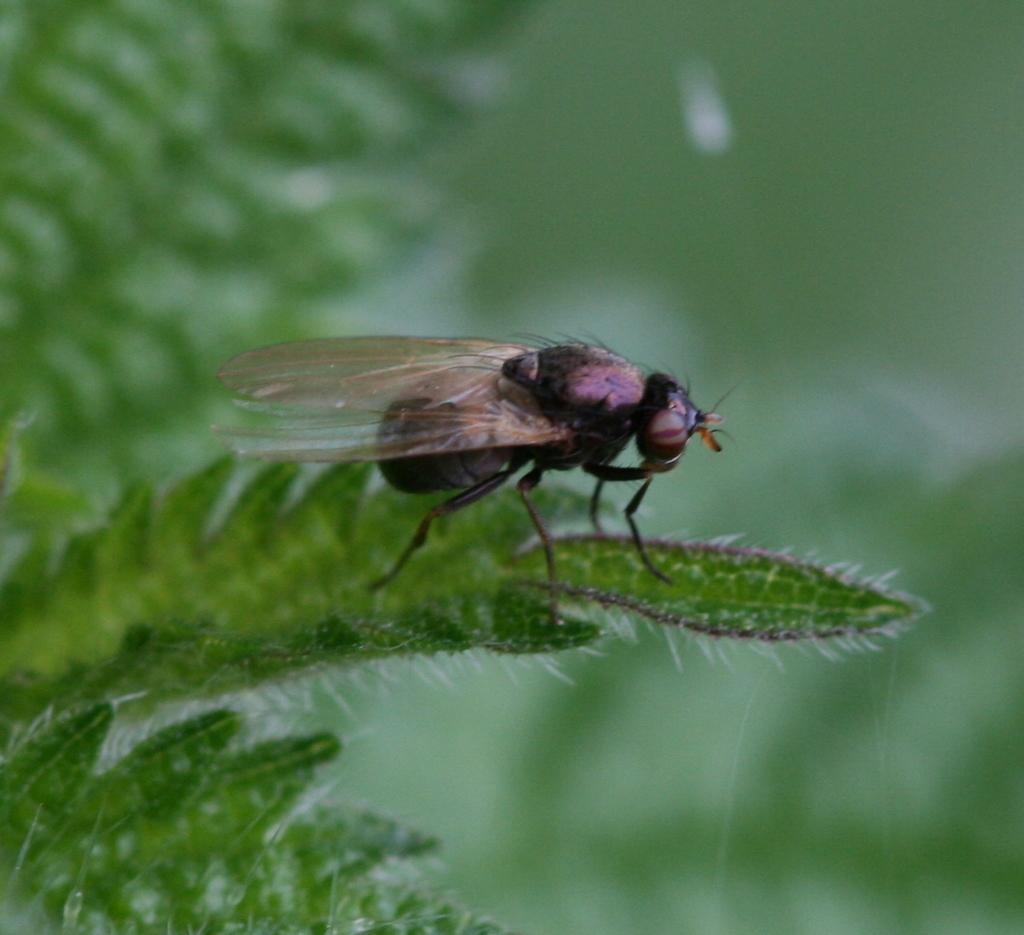Can you describe this image briefly? In this image we can see a insect on the leaves. In the background of the image is in a blur. 